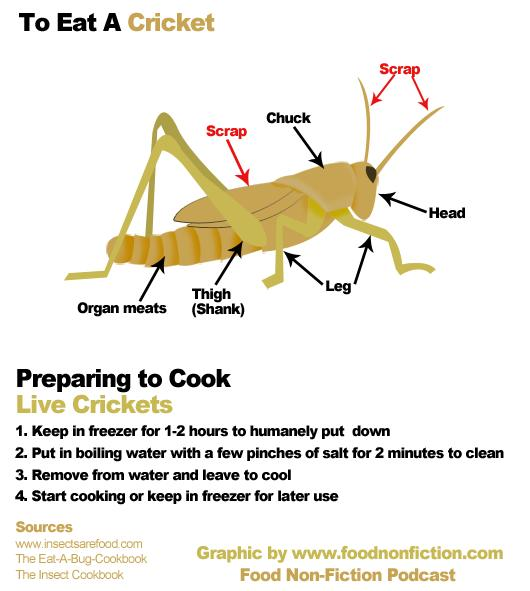Draw attention to some important aspects in this diagram. The selected answer to the question "Which parts of the cricket are to be removed before cooking, Leg, Chuck, Antennae, Thigh, or Wings?" is Antennae and Wings. 